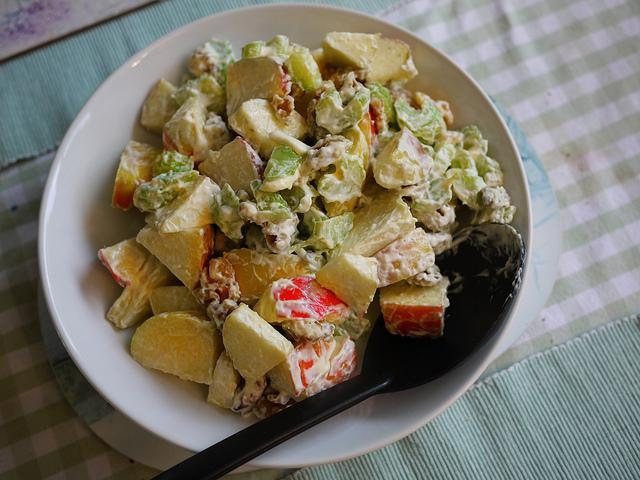What type of utensil is in the bowl? Please explain your reasoning. spoon. Anyone can see what type of utensil this is by its design. 